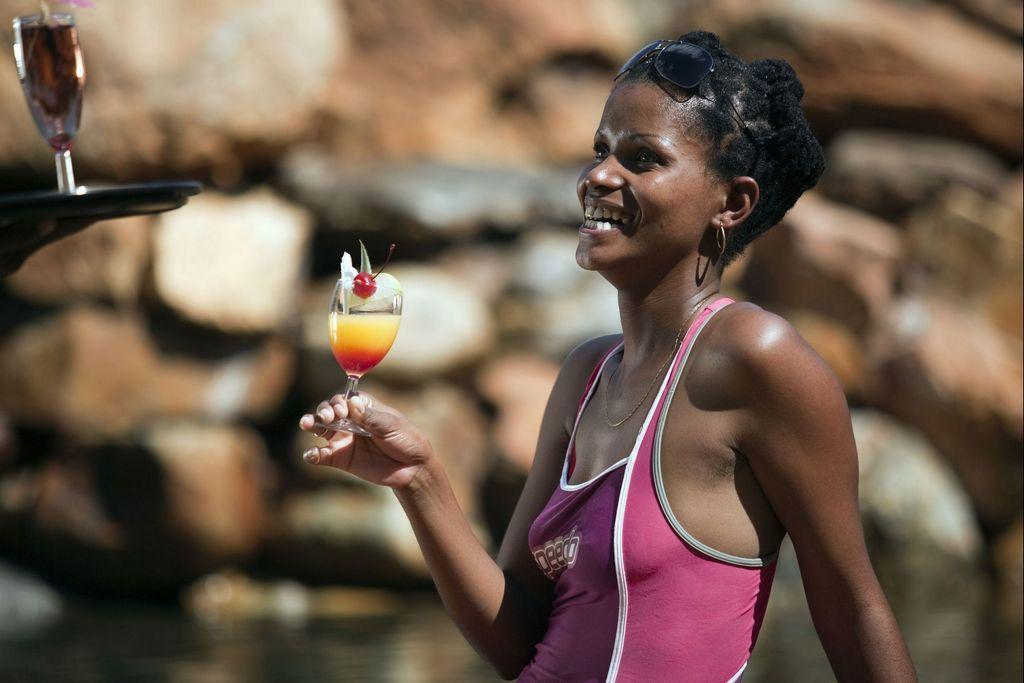What is the main subject of the image? There is a person in the image. What is the person holding in the image? The person is holding a glass. Where is the other glass located in the image? There is a glass in the top left of the image. Can you describe the background of the image? The background of the image is blurred. What type of disgust can be seen on the person's face in the image? There is no indication of disgust on the person's face in the image. How many feet are visible in the image? There is no foot visible in the image; it only shows a person holding a glass and a glass in the top left corner. 